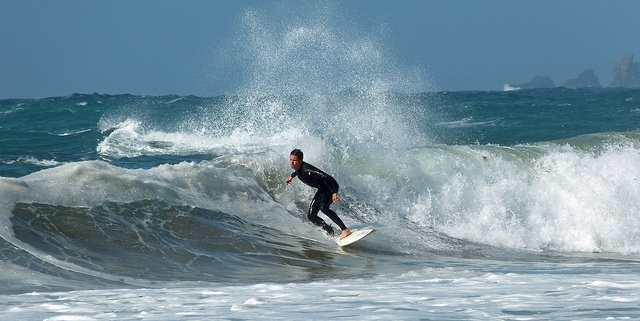Describe the objects in this image and their specific colors. I can see people in gray, black, maroon, and brown tones and surfboard in gray, ivory, darkgray, and lightgray tones in this image. 